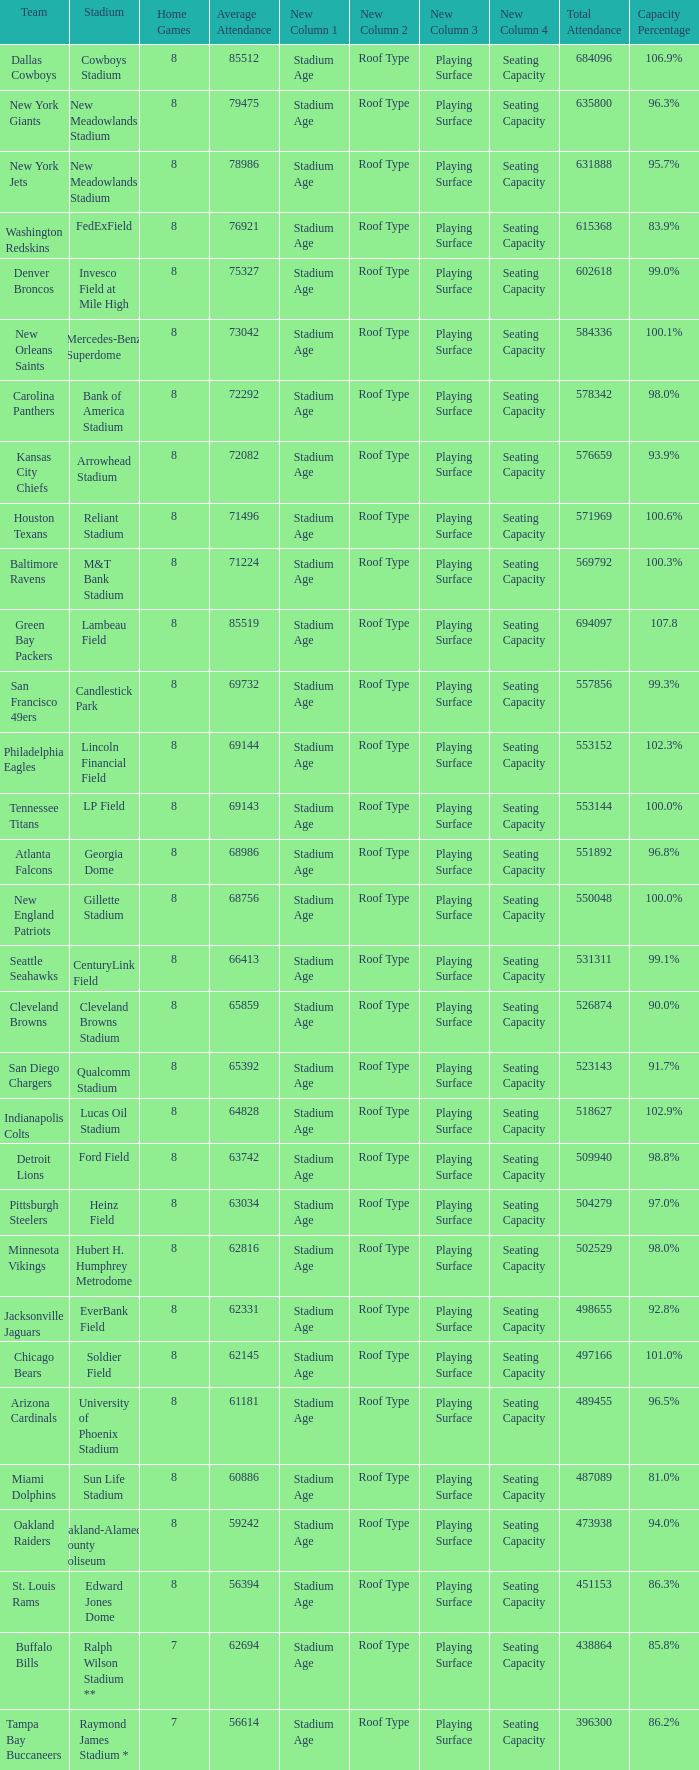How many home games are listed when the average attendance is 79475? 1.0. 